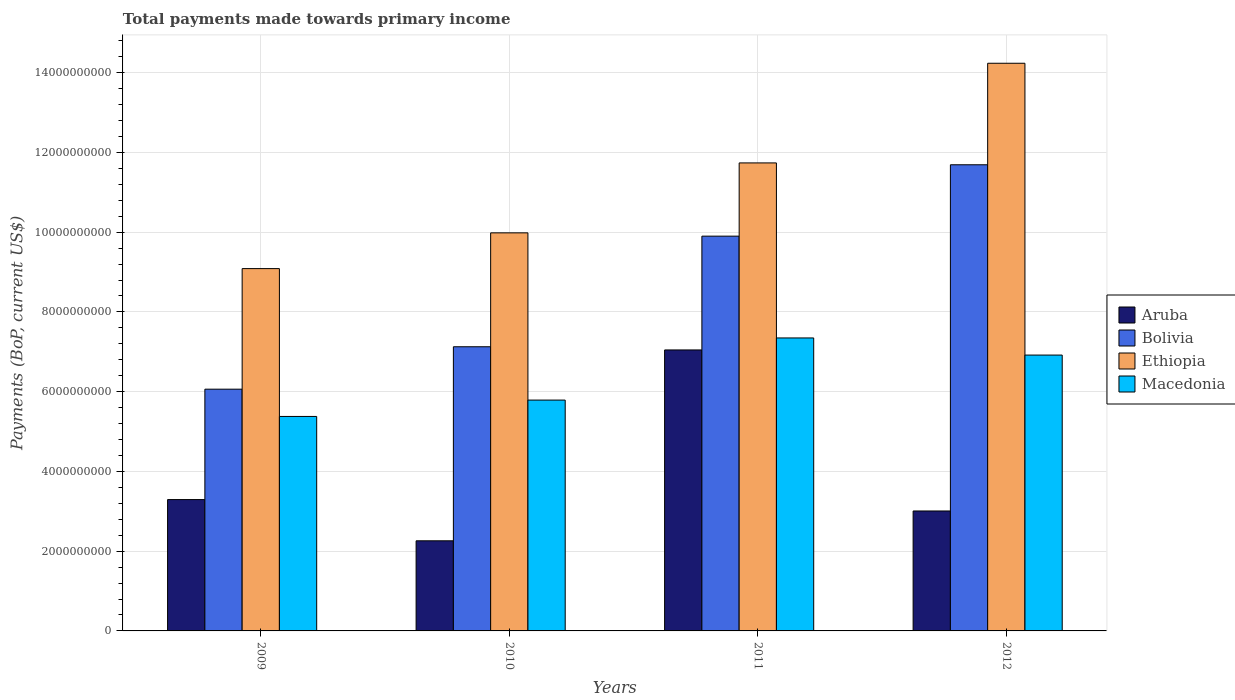How many bars are there on the 4th tick from the right?
Offer a terse response. 4. What is the label of the 1st group of bars from the left?
Make the answer very short. 2009. What is the total payments made towards primary income in Macedonia in 2011?
Offer a terse response. 7.35e+09. Across all years, what is the maximum total payments made towards primary income in Aruba?
Ensure brevity in your answer.  7.05e+09. Across all years, what is the minimum total payments made towards primary income in Ethiopia?
Your answer should be compact. 9.09e+09. In which year was the total payments made towards primary income in Macedonia maximum?
Provide a succinct answer. 2011. In which year was the total payments made towards primary income in Ethiopia minimum?
Give a very brief answer. 2009. What is the total total payments made towards primary income in Macedonia in the graph?
Offer a very short reply. 2.54e+1. What is the difference between the total payments made towards primary income in Aruba in 2009 and that in 2012?
Provide a short and direct response. 2.86e+08. What is the difference between the total payments made towards primary income in Macedonia in 2010 and the total payments made towards primary income in Aruba in 2009?
Keep it short and to the point. 2.49e+09. What is the average total payments made towards primary income in Bolivia per year?
Give a very brief answer. 8.69e+09. In the year 2012, what is the difference between the total payments made towards primary income in Ethiopia and total payments made towards primary income in Macedonia?
Make the answer very short. 7.32e+09. In how many years, is the total payments made towards primary income in Ethiopia greater than 14000000000 US$?
Provide a succinct answer. 1. What is the ratio of the total payments made towards primary income in Ethiopia in 2009 to that in 2012?
Your response must be concise. 0.64. What is the difference between the highest and the second highest total payments made towards primary income in Bolivia?
Ensure brevity in your answer.  1.79e+09. What is the difference between the highest and the lowest total payments made towards primary income in Ethiopia?
Offer a terse response. 5.15e+09. Is the sum of the total payments made towards primary income in Ethiopia in 2010 and 2012 greater than the maximum total payments made towards primary income in Macedonia across all years?
Ensure brevity in your answer.  Yes. What does the 1st bar from the left in 2009 represents?
Offer a terse response. Aruba. What does the 1st bar from the right in 2009 represents?
Keep it short and to the point. Macedonia. Is it the case that in every year, the sum of the total payments made towards primary income in Bolivia and total payments made towards primary income in Ethiopia is greater than the total payments made towards primary income in Aruba?
Provide a short and direct response. Yes. How many bars are there?
Your answer should be very brief. 16. Are all the bars in the graph horizontal?
Make the answer very short. No. What is the difference between two consecutive major ticks on the Y-axis?
Provide a succinct answer. 2.00e+09. Are the values on the major ticks of Y-axis written in scientific E-notation?
Provide a succinct answer. No. Does the graph contain any zero values?
Ensure brevity in your answer.  No. Does the graph contain grids?
Your response must be concise. Yes. Where does the legend appear in the graph?
Give a very brief answer. Center right. What is the title of the graph?
Keep it short and to the point. Total payments made towards primary income. Does "Myanmar" appear as one of the legend labels in the graph?
Offer a terse response. No. What is the label or title of the Y-axis?
Offer a very short reply. Payments (BoP, current US$). What is the Payments (BoP, current US$) of Aruba in 2009?
Provide a succinct answer. 3.29e+09. What is the Payments (BoP, current US$) of Bolivia in 2009?
Your answer should be very brief. 6.06e+09. What is the Payments (BoP, current US$) of Ethiopia in 2009?
Give a very brief answer. 9.09e+09. What is the Payments (BoP, current US$) of Macedonia in 2009?
Your answer should be very brief. 5.38e+09. What is the Payments (BoP, current US$) of Aruba in 2010?
Make the answer very short. 2.26e+09. What is the Payments (BoP, current US$) in Bolivia in 2010?
Ensure brevity in your answer.  7.13e+09. What is the Payments (BoP, current US$) of Ethiopia in 2010?
Ensure brevity in your answer.  9.98e+09. What is the Payments (BoP, current US$) in Macedonia in 2010?
Offer a terse response. 5.79e+09. What is the Payments (BoP, current US$) of Aruba in 2011?
Your response must be concise. 7.05e+09. What is the Payments (BoP, current US$) in Bolivia in 2011?
Offer a terse response. 9.90e+09. What is the Payments (BoP, current US$) of Ethiopia in 2011?
Offer a very short reply. 1.17e+1. What is the Payments (BoP, current US$) in Macedonia in 2011?
Offer a terse response. 7.35e+09. What is the Payments (BoP, current US$) in Aruba in 2012?
Provide a short and direct response. 3.01e+09. What is the Payments (BoP, current US$) of Bolivia in 2012?
Provide a succinct answer. 1.17e+1. What is the Payments (BoP, current US$) of Ethiopia in 2012?
Offer a very short reply. 1.42e+1. What is the Payments (BoP, current US$) of Macedonia in 2012?
Your answer should be very brief. 6.92e+09. Across all years, what is the maximum Payments (BoP, current US$) in Aruba?
Ensure brevity in your answer.  7.05e+09. Across all years, what is the maximum Payments (BoP, current US$) in Bolivia?
Your answer should be compact. 1.17e+1. Across all years, what is the maximum Payments (BoP, current US$) in Ethiopia?
Your answer should be compact. 1.42e+1. Across all years, what is the maximum Payments (BoP, current US$) in Macedonia?
Your answer should be very brief. 7.35e+09. Across all years, what is the minimum Payments (BoP, current US$) of Aruba?
Provide a succinct answer. 2.26e+09. Across all years, what is the minimum Payments (BoP, current US$) in Bolivia?
Give a very brief answer. 6.06e+09. Across all years, what is the minimum Payments (BoP, current US$) of Ethiopia?
Make the answer very short. 9.09e+09. Across all years, what is the minimum Payments (BoP, current US$) of Macedonia?
Provide a succinct answer. 5.38e+09. What is the total Payments (BoP, current US$) in Aruba in the graph?
Give a very brief answer. 1.56e+1. What is the total Payments (BoP, current US$) in Bolivia in the graph?
Offer a very short reply. 3.48e+1. What is the total Payments (BoP, current US$) in Ethiopia in the graph?
Ensure brevity in your answer.  4.50e+1. What is the total Payments (BoP, current US$) of Macedonia in the graph?
Give a very brief answer. 2.54e+1. What is the difference between the Payments (BoP, current US$) of Aruba in 2009 and that in 2010?
Offer a terse response. 1.03e+09. What is the difference between the Payments (BoP, current US$) of Bolivia in 2009 and that in 2010?
Provide a succinct answer. -1.06e+09. What is the difference between the Payments (BoP, current US$) of Ethiopia in 2009 and that in 2010?
Keep it short and to the point. -8.96e+08. What is the difference between the Payments (BoP, current US$) in Macedonia in 2009 and that in 2010?
Make the answer very short. -4.10e+08. What is the difference between the Payments (BoP, current US$) in Aruba in 2009 and that in 2011?
Make the answer very short. -3.75e+09. What is the difference between the Payments (BoP, current US$) in Bolivia in 2009 and that in 2011?
Provide a succinct answer. -3.84e+09. What is the difference between the Payments (BoP, current US$) in Ethiopia in 2009 and that in 2011?
Keep it short and to the point. -2.65e+09. What is the difference between the Payments (BoP, current US$) of Macedonia in 2009 and that in 2011?
Provide a succinct answer. -1.97e+09. What is the difference between the Payments (BoP, current US$) in Aruba in 2009 and that in 2012?
Offer a very short reply. 2.86e+08. What is the difference between the Payments (BoP, current US$) in Bolivia in 2009 and that in 2012?
Your response must be concise. -5.63e+09. What is the difference between the Payments (BoP, current US$) in Ethiopia in 2009 and that in 2012?
Ensure brevity in your answer.  -5.15e+09. What is the difference between the Payments (BoP, current US$) in Macedonia in 2009 and that in 2012?
Offer a very short reply. -1.54e+09. What is the difference between the Payments (BoP, current US$) in Aruba in 2010 and that in 2011?
Your response must be concise. -4.79e+09. What is the difference between the Payments (BoP, current US$) in Bolivia in 2010 and that in 2011?
Offer a very short reply. -2.77e+09. What is the difference between the Payments (BoP, current US$) of Ethiopia in 2010 and that in 2011?
Your answer should be very brief. -1.75e+09. What is the difference between the Payments (BoP, current US$) of Macedonia in 2010 and that in 2011?
Give a very brief answer. -1.56e+09. What is the difference between the Payments (BoP, current US$) in Aruba in 2010 and that in 2012?
Ensure brevity in your answer.  -7.48e+08. What is the difference between the Payments (BoP, current US$) in Bolivia in 2010 and that in 2012?
Give a very brief answer. -4.56e+09. What is the difference between the Payments (BoP, current US$) of Ethiopia in 2010 and that in 2012?
Offer a terse response. -4.25e+09. What is the difference between the Payments (BoP, current US$) in Macedonia in 2010 and that in 2012?
Make the answer very short. -1.13e+09. What is the difference between the Payments (BoP, current US$) in Aruba in 2011 and that in 2012?
Keep it short and to the point. 4.04e+09. What is the difference between the Payments (BoP, current US$) of Bolivia in 2011 and that in 2012?
Provide a succinct answer. -1.79e+09. What is the difference between the Payments (BoP, current US$) in Ethiopia in 2011 and that in 2012?
Ensure brevity in your answer.  -2.50e+09. What is the difference between the Payments (BoP, current US$) of Macedonia in 2011 and that in 2012?
Offer a terse response. 4.29e+08. What is the difference between the Payments (BoP, current US$) of Aruba in 2009 and the Payments (BoP, current US$) of Bolivia in 2010?
Your answer should be very brief. -3.83e+09. What is the difference between the Payments (BoP, current US$) of Aruba in 2009 and the Payments (BoP, current US$) of Ethiopia in 2010?
Make the answer very short. -6.69e+09. What is the difference between the Payments (BoP, current US$) of Aruba in 2009 and the Payments (BoP, current US$) of Macedonia in 2010?
Your answer should be compact. -2.49e+09. What is the difference between the Payments (BoP, current US$) in Bolivia in 2009 and the Payments (BoP, current US$) in Ethiopia in 2010?
Keep it short and to the point. -3.92e+09. What is the difference between the Payments (BoP, current US$) in Bolivia in 2009 and the Payments (BoP, current US$) in Macedonia in 2010?
Your answer should be very brief. 2.73e+08. What is the difference between the Payments (BoP, current US$) in Ethiopia in 2009 and the Payments (BoP, current US$) in Macedonia in 2010?
Your answer should be compact. 3.30e+09. What is the difference between the Payments (BoP, current US$) of Aruba in 2009 and the Payments (BoP, current US$) of Bolivia in 2011?
Give a very brief answer. -6.61e+09. What is the difference between the Payments (BoP, current US$) of Aruba in 2009 and the Payments (BoP, current US$) of Ethiopia in 2011?
Your response must be concise. -8.44e+09. What is the difference between the Payments (BoP, current US$) of Aruba in 2009 and the Payments (BoP, current US$) of Macedonia in 2011?
Offer a terse response. -4.05e+09. What is the difference between the Payments (BoP, current US$) of Bolivia in 2009 and the Payments (BoP, current US$) of Ethiopia in 2011?
Make the answer very short. -5.67e+09. What is the difference between the Payments (BoP, current US$) of Bolivia in 2009 and the Payments (BoP, current US$) of Macedonia in 2011?
Your answer should be compact. -1.28e+09. What is the difference between the Payments (BoP, current US$) in Ethiopia in 2009 and the Payments (BoP, current US$) in Macedonia in 2011?
Provide a short and direct response. 1.74e+09. What is the difference between the Payments (BoP, current US$) of Aruba in 2009 and the Payments (BoP, current US$) of Bolivia in 2012?
Your answer should be compact. -8.40e+09. What is the difference between the Payments (BoP, current US$) of Aruba in 2009 and the Payments (BoP, current US$) of Ethiopia in 2012?
Offer a terse response. -1.09e+1. What is the difference between the Payments (BoP, current US$) of Aruba in 2009 and the Payments (BoP, current US$) of Macedonia in 2012?
Your answer should be very brief. -3.62e+09. What is the difference between the Payments (BoP, current US$) in Bolivia in 2009 and the Payments (BoP, current US$) in Ethiopia in 2012?
Make the answer very short. -8.17e+09. What is the difference between the Payments (BoP, current US$) in Bolivia in 2009 and the Payments (BoP, current US$) in Macedonia in 2012?
Offer a terse response. -8.55e+08. What is the difference between the Payments (BoP, current US$) of Ethiopia in 2009 and the Payments (BoP, current US$) of Macedonia in 2012?
Your answer should be compact. 2.17e+09. What is the difference between the Payments (BoP, current US$) of Aruba in 2010 and the Payments (BoP, current US$) of Bolivia in 2011?
Give a very brief answer. -7.64e+09. What is the difference between the Payments (BoP, current US$) of Aruba in 2010 and the Payments (BoP, current US$) of Ethiopia in 2011?
Your answer should be very brief. -9.48e+09. What is the difference between the Payments (BoP, current US$) in Aruba in 2010 and the Payments (BoP, current US$) in Macedonia in 2011?
Offer a terse response. -5.09e+09. What is the difference between the Payments (BoP, current US$) of Bolivia in 2010 and the Payments (BoP, current US$) of Ethiopia in 2011?
Offer a very short reply. -4.61e+09. What is the difference between the Payments (BoP, current US$) of Bolivia in 2010 and the Payments (BoP, current US$) of Macedonia in 2011?
Give a very brief answer. -2.21e+08. What is the difference between the Payments (BoP, current US$) of Ethiopia in 2010 and the Payments (BoP, current US$) of Macedonia in 2011?
Keep it short and to the point. 2.64e+09. What is the difference between the Payments (BoP, current US$) in Aruba in 2010 and the Payments (BoP, current US$) in Bolivia in 2012?
Give a very brief answer. -9.43e+09. What is the difference between the Payments (BoP, current US$) of Aruba in 2010 and the Payments (BoP, current US$) of Ethiopia in 2012?
Give a very brief answer. -1.20e+1. What is the difference between the Payments (BoP, current US$) of Aruba in 2010 and the Payments (BoP, current US$) of Macedonia in 2012?
Offer a terse response. -4.66e+09. What is the difference between the Payments (BoP, current US$) in Bolivia in 2010 and the Payments (BoP, current US$) in Ethiopia in 2012?
Your response must be concise. -7.11e+09. What is the difference between the Payments (BoP, current US$) in Bolivia in 2010 and the Payments (BoP, current US$) in Macedonia in 2012?
Your answer should be compact. 2.09e+08. What is the difference between the Payments (BoP, current US$) of Ethiopia in 2010 and the Payments (BoP, current US$) of Macedonia in 2012?
Your response must be concise. 3.06e+09. What is the difference between the Payments (BoP, current US$) of Aruba in 2011 and the Payments (BoP, current US$) of Bolivia in 2012?
Provide a succinct answer. -4.64e+09. What is the difference between the Payments (BoP, current US$) of Aruba in 2011 and the Payments (BoP, current US$) of Ethiopia in 2012?
Ensure brevity in your answer.  -7.19e+09. What is the difference between the Payments (BoP, current US$) in Aruba in 2011 and the Payments (BoP, current US$) in Macedonia in 2012?
Make the answer very short. 1.29e+08. What is the difference between the Payments (BoP, current US$) of Bolivia in 2011 and the Payments (BoP, current US$) of Ethiopia in 2012?
Your answer should be compact. -4.34e+09. What is the difference between the Payments (BoP, current US$) in Bolivia in 2011 and the Payments (BoP, current US$) in Macedonia in 2012?
Provide a succinct answer. 2.98e+09. What is the difference between the Payments (BoP, current US$) in Ethiopia in 2011 and the Payments (BoP, current US$) in Macedonia in 2012?
Your answer should be very brief. 4.82e+09. What is the average Payments (BoP, current US$) of Aruba per year?
Make the answer very short. 3.90e+09. What is the average Payments (BoP, current US$) in Bolivia per year?
Keep it short and to the point. 8.69e+09. What is the average Payments (BoP, current US$) in Ethiopia per year?
Provide a short and direct response. 1.13e+1. What is the average Payments (BoP, current US$) of Macedonia per year?
Provide a succinct answer. 6.36e+09. In the year 2009, what is the difference between the Payments (BoP, current US$) of Aruba and Payments (BoP, current US$) of Bolivia?
Ensure brevity in your answer.  -2.77e+09. In the year 2009, what is the difference between the Payments (BoP, current US$) of Aruba and Payments (BoP, current US$) of Ethiopia?
Make the answer very short. -5.79e+09. In the year 2009, what is the difference between the Payments (BoP, current US$) in Aruba and Payments (BoP, current US$) in Macedonia?
Offer a very short reply. -2.08e+09. In the year 2009, what is the difference between the Payments (BoP, current US$) of Bolivia and Payments (BoP, current US$) of Ethiopia?
Give a very brief answer. -3.02e+09. In the year 2009, what is the difference between the Payments (BoP, current US$) of Bolivia and Payments (BoP, current US$) of Macedonia?
Provide a short and direct response. 6.84e+08. In the year 2009, what is the difference between the Payments (BoP, current US$) of Ethiopia and Payments (BoP, current US$) of Macedonia?
Ensure brevity in your answer.  3.71e+09. In the year 2010, what is the difference between the Payments (BoP, current US$) of Aruba and Payments (BoP, current US$) of Bolivia?
Provide a succinct answer. -4.87e+09. In the year 2010, what is the difference between the Payments (BoP, current US$) of Aruba and Payments (BoP, current US$) of Ethiopia?
Keep it short and to the point. -7.72e+09. In the year 2010, what is the difference between the Payments (BoP, current US$) of Aruba and Payments (BoP, current US$) of Macedonia?
Your answer should be very brief. -3.53e+09. In the year 2010, what is the difference between the Payments (BoP, current US$) of Bolivia and Payments (BoP, current US$) of Ethiopia?
Keep it short and to the point. -2.86e+09. In the year 2010, what is the difference between the Payments (BoP, current US$) in Bolivia and Payments (BoP, current US$) in Macedonia?
Ensure brevity in your answer.  1.34e+09. In the year 2010, what is the difference between the Payments (BoP, current US$) in Ethiopia and Payments (BoP, current US$) in Macedonia?
Offer a terse response. 4.19e+09. In the year 2011, what is the difference between the Payments (BoP, current US$) of Aruba and Payments (BoP, current US$) of Bolivia?
Your response must be concise. -2.85e+09. In the year 2011, what is the difference between the Payments (BoP, current US$) of Aruba and Payments (BoP, current US$) of Ethiopia?
Ensure brevity in your answer.  -4.69e+09. In the year 2011, what is the difference between the Payments (BoP, current US$) of Aruba and Payments (BoP, current US$) of Macedonia?
Offer a terse response. -3.01e+08. In the year 2011, what is the difference between the Payments (BoP, current US$) in Bolivia and Payments (BoP, current US$) in Ethiopia?
Your answer should be compact. -1.84e+09. In the year 2011, what is the difference between the Payments (BoP, current US$) in Bolivia and Payments (BoP, current US$) in Macedonia?
Keep it short and to the point. 2.55e+09. In the year 2011, what is the difference between the Payments (BoP, current US$) of Ethiopia and Payments (BoP, current US$) of Macedonia?
Offer a terse response. 4.39e+09. In the year 2012, what is the difference between the Payments (BoP, current US$) of Aruba and Payments (BoP, current US$) of Bolivia?
Offer a very short reply. -8.68e+09. In the year 2012, what is the difference between the Payments (BoP, current US$) in Aruba and Payments (BoP, current US$) in Ethiopia?
Your answer should be compact. -1.12e+1. In the year 2012, what is the difference between the Payments (BoP, current US$) in Aruba and Payments (BoP, current US$) in Macedonia?
Make the answer very short. -3.91e+09. In the year 2012, what is the difference between the Payments (BoP, current US$) in Bolivia and Payments (BoP, current US$) in Ethiopia?
Make the answer very short. -2.55e+09. In the year 2012, what is the difference between the Payments (BoP, current US$) of Bolivia and Payments (BoP, current US$) of Macedonia?
Offer a terse response. 4.77e+09. In the year 2012, what is the difference between the Payments (BoP, current US$) of Ethiopia and Payments (BoP, current US$) of Macedonia?
Your response must be concise. 7.32e+09. What is the ratio of the Payments (BoP, current US$) in Aruba in 2009 to that in 2010?
Offer a very short reply. 1.46. What is the ratio of the Payments (BoP, current US$) of Bolivia in 2009 to that in 2010?
Your response must be concise. 0.85. What is the ratio of the Payments (BoP, current US$) of Ethiopia in 2009 to that in 2010?
Offer a very short reply. 0.91. What is the ratio of the Payments (BoP, current US$) in Macedonia in 2009 to that in 2010?
Offer a terse response. 0.93. What is the ratio of the Payments (BoP, current US$) in Aruba in 2009 to that in 2011?
Your answer should be compact. 0.47. What is the ratio of the Payments (BoP, current US$) of Bolivia in 2009 to that in 2011?
Offer a terse response. 0.61. What is the ratio of the Payments (BoP, current US$) in Ethiopia in 2009 to that in 2011?
Offer a terse response. 0.77. What is the ratio of the Payments (BoP, current US$) of Macedonia in 2009 to that in 2011?
Offer a very short reply. 0.73. What is the ratio of the Payments (BoP, current US$) of Aruba in 2009 to that in 2012?
Offer a very short reply. 1.1. What is the ratio of the Payments (BoP, current US$) of Bolivia in 2009 to that in 2012?
Your answer should be compact. 0.52. What is the ratio of the Payments (BoP, current US$) of Ethiopia in 2009 to that in 2012?
Your response must be concise. 0.64. What is the ratio of the Payments (BoP, current US$) in Macedonia in 2009 to that in 2012?
Provide a short and direct response. 0.78. What is the ratio of the Payments (BoP, current US$) in Aruba in 2010 to that in 2011?
Offer a very short reply. 0.32. What is the ratio of the Payments (BoP, current US$) in Bolivia in 2010 to that in 2011?
Provide a succinct answer. 0.72. What is the ratio of the Payments (BoP, current US$) of Ethiopia in 2010 to that in 2011?
Offer a terse response. 0.85. What is the ratio of the Payments (BoP, current US$) in Macedonia in 2010 to that in 2011?
Offer a terse response. 0.79. What is the ratio of the Payments (BoP, current US$) in Aruba in 2010 to that in 2012?
Make the answer very short. 0.75. What is the ratio of the Payments (BoP, current US$) in Bolivia in 2010 to that in 2012?
Keep it short and to the point. 0.61. What is the ratio of the Payments (BoP, current US$) of Ethiopia in 2010 to that in 2012?
Offer a terse response. 0.7. What is the ratio of the Payments (BoP, current US$) in Macedonia in 2010 to that in 2012?
Give a very brief answer. 0.84. What is the ratio of the Payments (BoP, current US$) in Aruba in 2011 to that in 2012?
Ensure brevity in your answer.  2.34. What is the ratio of the Payments (BoP, current US$) in Bolivia in 2011 to that in 2012?
Keep it short and to the point. 0.85. What is the ratio of the Payments (BoP, current US$) in Ethiopia in 2011 to that in 2012?
Make the answer very short. 0.82. What is the ratio of the Payments (BoP, current US$) of Macedonia in 2011 to that in 2012?
Your answer should be very brief. 1.06. What is the difference between the highest and the second highest Payments (BoP, current US$) in Aruba?
Offer a very short reply. 3.75e+09. What is the difference between the highest and the second highest Payments (BoP, current US$) of Bolivia?
Offer a very short reply. 1.79e+09. What is the difference between the highest and the second highest Payments (BoP, current US$) of Ethiopia?
Keep it short and to the point. 2.50e+09. What is the difference between the highest and the second highest Payments (BoP, current US$) of Macedonia?
Give a very brief answer. 4.29e+08. What is the difference between the highest and the lowest Payments (BoP, current US$) of Aruba?
Make the answer very short. 4.79e+09. What is the difference between the highest and the lowest Payments (BoP, current US$) in Bolivia?
Offer a very short reply. 5.63e+09. What is the difference between the highest and the lowest Payments (BoP, current US$) of Ethiopia?
Your response must be concise. 5.15e+09. What is the difference between the highest and the lowest Payments (BoP, current US$) of Macedonia?
Give a very brief answer. 1.97e+09. 